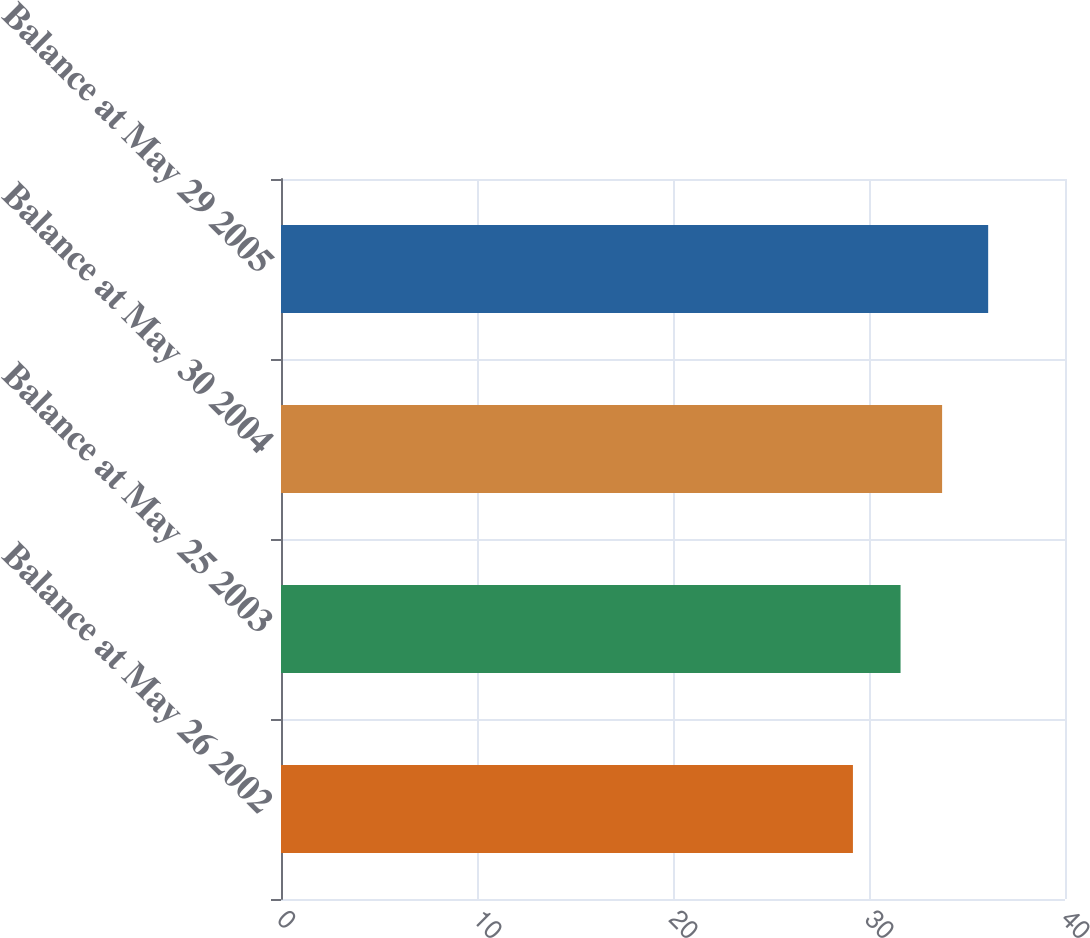<chart> <loc_0><loc_0><loc_500><loc_500><bar_chart><fcel>Balance at May 26 2002<fcel>Balance at May 25 2003<fcel>Balance at May 30 2004<fcel>Balance at May 29 2005<nl><fcel>29.18<fcel>31.61<fcel>33.73<fcel>36.08<nl></chart> 